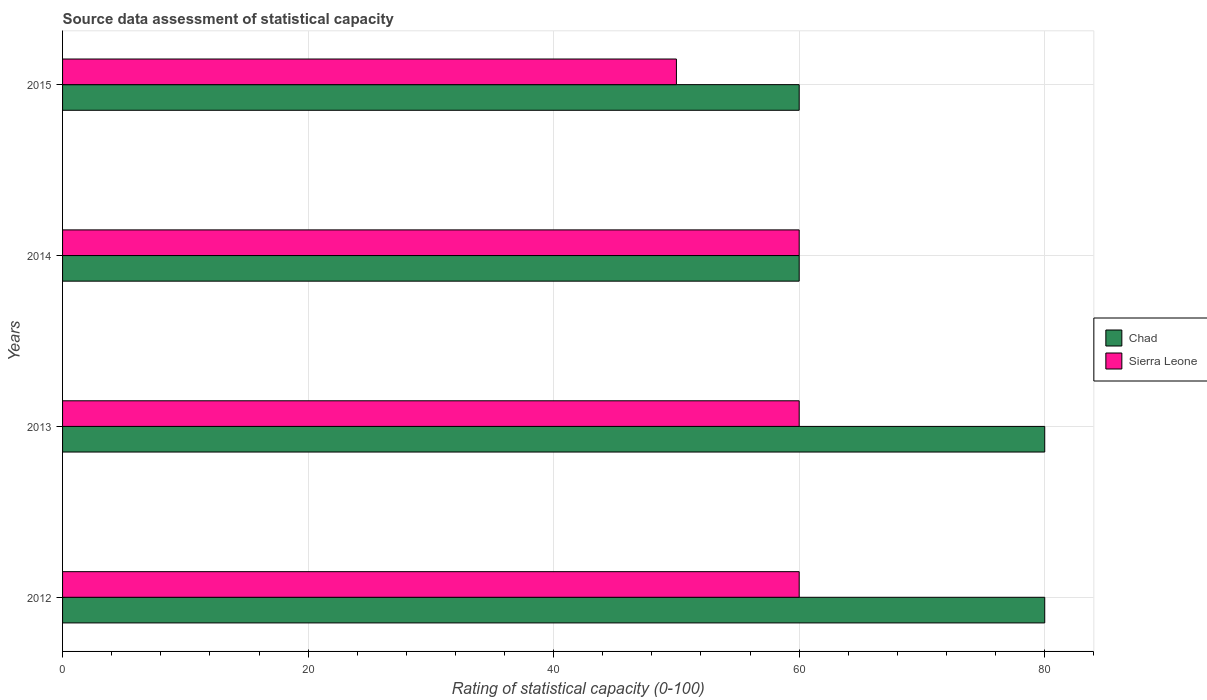How many different coloured bars are there?
Make the answer very short. 2. How many groups of bars are there?
Offer a terse response. 4. How many bars are there on the 1st tick from the top?
Offer a terse response. 2. How many bars are there on the 2nd tick from the bottom?
Make the answer very short. 2. What is the label of the 4th group of bars from the top?
Offer a very short reply. 2012. In how many cases, is the number of bars for a given year not equal to the number of legend labels?
Offer a terse response. 0. What is the rating of statistical capacity in Chad in 2013?
Make the answer very short. 80. Across all years, what is the maximum rating of statistical capacity in Chad?
Your answer should be very brief. 80. Across all years, what is the minimum rating of statistical capacity in Chad?
Make the answer very short. 60. In which year was the rating of statistical capacity in Chad maximum?
Make the answer very short. 2012. In which year was the rating of statistical capacity in Sierra Leone minimum?
Offer a terse response. 2015. What is the total rating of statistical capacity in Chad in the graph?
Ensure brevity in your answer.  280. What is the difference between the rating of statistical capacity in Sierra Leone in 2012 and that in 2015?
Offer a terse response. 10. What is the difference between the rating of statistical capacity in Sierra Leone in 2014 and the rating of statistical capacity in Chad in 2013?
Your answer should be compact. -20. What is the average rating of statistical capacity in Chad per year?
Your answer should be compact. 70. In how many years, is the rating of statistical capacity in Sierra Leone greater than 4 ?
Your answer should be compact. 4. What is the ratio of the rating of statistical capacity in Sierra Leone in 2012 to that in 2014?
Keep it short and to the point. 1. Is the difference between the rating of statistical capacity in Chad in 2014 and 2015 greater than the difference between the rating of statistical capacity in Sierra Leone in 2014 and 2015?
Offer a very short reply. No. What is the difference between the highest and the lowest rating of statistical capacity in Chad?
Give a very brief answer. 20. In how many years, is the rating of statistical capacity in Chad greater than the average rating of statistical capacity in Chad taken over all years?
Make the answer very short. 2. Is the sum of the rating of statistical capacity in Chad in 2012 and 2015 greater than the maximum rating of statistical capacity in Sierra Leone across all years?
Make the answer very short. Yes. What does the 2nd bar from the top in 2014 represents?
Keep it short and to the point. Chad. What does the 1st bar from the bottom in 2014 represents?
Offer a terse response. Chad. Are all the bars in the graph horizontal?
Ensure brevity in your answer.  Yes. Are the values on the major ticks of X-axis written in scientific E-notation?
Provide a succinct answer. No. How are the legend labels stacked?
Give a very brief answer. Vertical. What is the title of the graph?
Provide a succinct answer. Source data assessment of statistical capacity. Does "Equatorial Guinea" appear as one of the legend labels in the graph?
Provide a short and direct response. No. What is the label or title of the X-axis?
Make the answer very short. Rating of statistical capacity (0-100). What is the label or title of the Y-axis?
Keep it short and to the point. Years. What is the Rating of statistical capacity (0-100) of Chad in 2012?
Offer a terse response. 80. What is the Rating of statistical capacity (0-100) of Sierra Leone in 2012?
Ensure brevity in your answer.  60. What is the Rating of statistical capacity (0-100) of Chad in 2013?
Offer a very short reply. 80. What is the Rating of statistical capacity (0-100) of Sierra Leone in 2013?
Keep it short and to the point. 60. What is the Rating of statistical capacity (0-100) of Sierra Leone in 2014?
Your answer should be compact. 60. Across all years, what is the maximum Rating of statistical capacity (0-100) of Chad?
Make the answer very short. 80. Across all years, what is the minimum Rating of statistical capacity (0-100) in Chad?
Provide a succinct answer. 60. What is the total Rating of statistical capacity (0-100) in Chad in the graph?
Provide a succinct answer. 280. What is the total Rating of statistical capacity (0-100) of Sierra Leone in the graph?
Offer a terse response. 230. What is the difference between the Rating of statistical capacity (0-100) in Sierra Leone in 2012 and that in 2014?
Ensure brevity in your answer.  0. What is the difference between the Rating of statistical capacity (0-100) in Chad in 2012 and that in 2015?
Offer a very short reply. 20. What is the difference between the Rating of statistical capacity (0-100) of Chad in 2013 and that in 2014?
Keep it short and to the point. 20. What is the difference between the Rating of statistical capacity (0-100) in Sierra Leone in 2014 and that in 2015?
Give a very brief answer. 10. What is the difference between the Rating of statistical capacity (0-100) in Chad in 2012 and the Rating of statistical capacity (0-100) in Sierra Leone in 2013?
Offer a terse response. 20. What is the difference between the Rating of statistical capacity (0-100) in Chad in 2012 and the Rating of statistical capacity (0-100) in Sierra Leone in 2015?
Your response must be concise. 30. What is the difference between the Rating of statistical capacity (0-100) in Chad in 2013 and the Rating of statistical capacity (0-100) in Sierra Leone in 2014?
Offer a terse response. 20. What is the difference between the Rating of statistical capacity (0-100) of Chad in 2013 and the Rating of statistical capacity (0-100) of Sierra Leone in 2015?
Your answer should be compact. 30. What is the difference between the Rating of statistical capacity (0-100) of Chad in 2014 and the Rating of statistical capacity (0-100) of Sierra Leone in 2015?
Give a very brief answer. 10. What is the average Rating of statistical capacity (0-100) in Sierra Leone per year?
Offer a terse response. 57.5. In the year 2012, what is the difference between the Rating of statistical capacity (0-100) in Chad and Rating of statistical capacity (0-100) in Sierra Leone?
Provide a short and direct response. 20. In the year 2015, what is the difference between the Rating of statistical capacity (0-100) of Chad and Rating of statistical capacity (0-100) of Sierra Leone?
Provide a succinct answer. 10. What is the ratio of the Rating of statistical capacity (0-100) in Chad in 2012 to that in 2013?
Offer a terse response. 1. What is the ratio of the Rating of statistical capacity (0-100) in Chad in 2012 to that in 2015?
Give a very brief answer. 1.33. What is the ratio of the Rating of statistical capacity (0-100) in Sierra Leone in 2012 to that in 2015?
Offer a very short reply. 1.2. What is the ratio of the Rating of statistical capacity (0-100) of Sierra Leone in 2013 to that in 2015?
Your answer should be very brief. 1.2. What is the ratio of the Rating of statistical capacity (0-100) in Chad in 2014 to that in 2015?
Give a very brief answer. 1. 